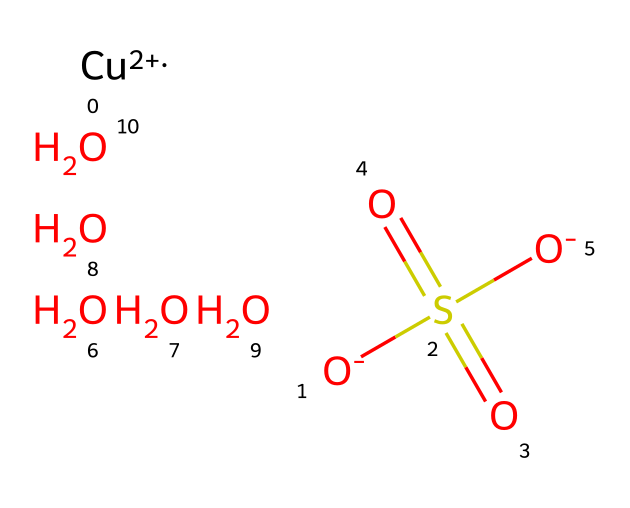What is the chemical name of this compound? The SMILES representation shows the elements present and their connectivity. The presence of copper, sulfur, and five water molecules indicates that this compound is copper sulfate pentahydrate.
Answer: copper sulfate pentahydrate How many oxygen atoms are present in this structure? By examining the structure, particularly the sulfate group, which has four oxygen atoms, and the five water molecules contributing another five oxygen atoms, the total adds up to nine.
Answer: nine What charge does the copper ion possess in this compound? The representation shows '[Cu+2]', which indicates that the copper ion has a +2 charge.
Answer: +2 How many water molecules are coordinated with the copper ion? The 'O.O.O.O.O' at the end of the SMILES shows that there are five water molecules (indicated by 'O') associated with the copper ion, confirming the 'pentahydrate' part of the name.
Answer: five Is copper sulfate pentahydrate classified as a coordination compound? Yes, because it consists of a central copper ion surrounded by ligands, which include the sulfate ion and water molecules, characteristic of coordination complexes.
Answer: yes Which part of the structure acts as the ligand? The sulfate portion, denoted as 'S(=O)(=O)[O-]', serves as a ligand, coordinating with the copper ion through its negatively charged oxygen atoms.
Answer: sulfate What is the role of the water molecules in this compound? The water molecules act as ligands in a hydrate complex, forming coordinate bonds with the copper ion, which stabilizes the structure.
Answer: ligands 